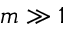<formula> <loc_0><loc_0><loc_500><loc_500>m \gg 1</formula> 